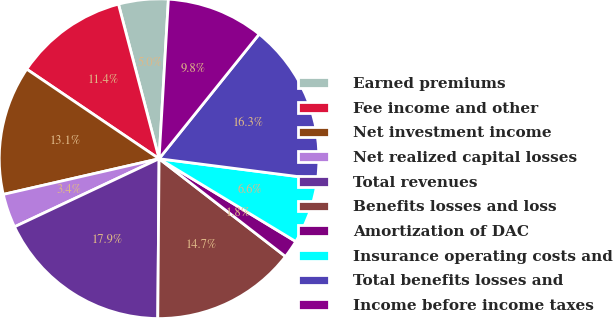<chart> <loc_0><loc_0><loc_500><loc_500><pie_chart><fcel>Earned premiums<fcel>Fee income and other<fcel>Net investment income<fcel>Net realized capital losses<fcel>Total revenues<fcel>Benefits losses and loss<fcel>Amortization of DAC<fcel>Insurance operating costs and<fcel>Total benefits losses and<fcel>Income before income taxes<nl><fcel>5.02%<fcel>11.44%<fcel>13.05%<fcel>3.42%<fcel>17.86%<fcel>14.65%<fcel>1.81%<fcel>6.63%<fcel>16.26%<fcel>9.84%<nl></chart> 